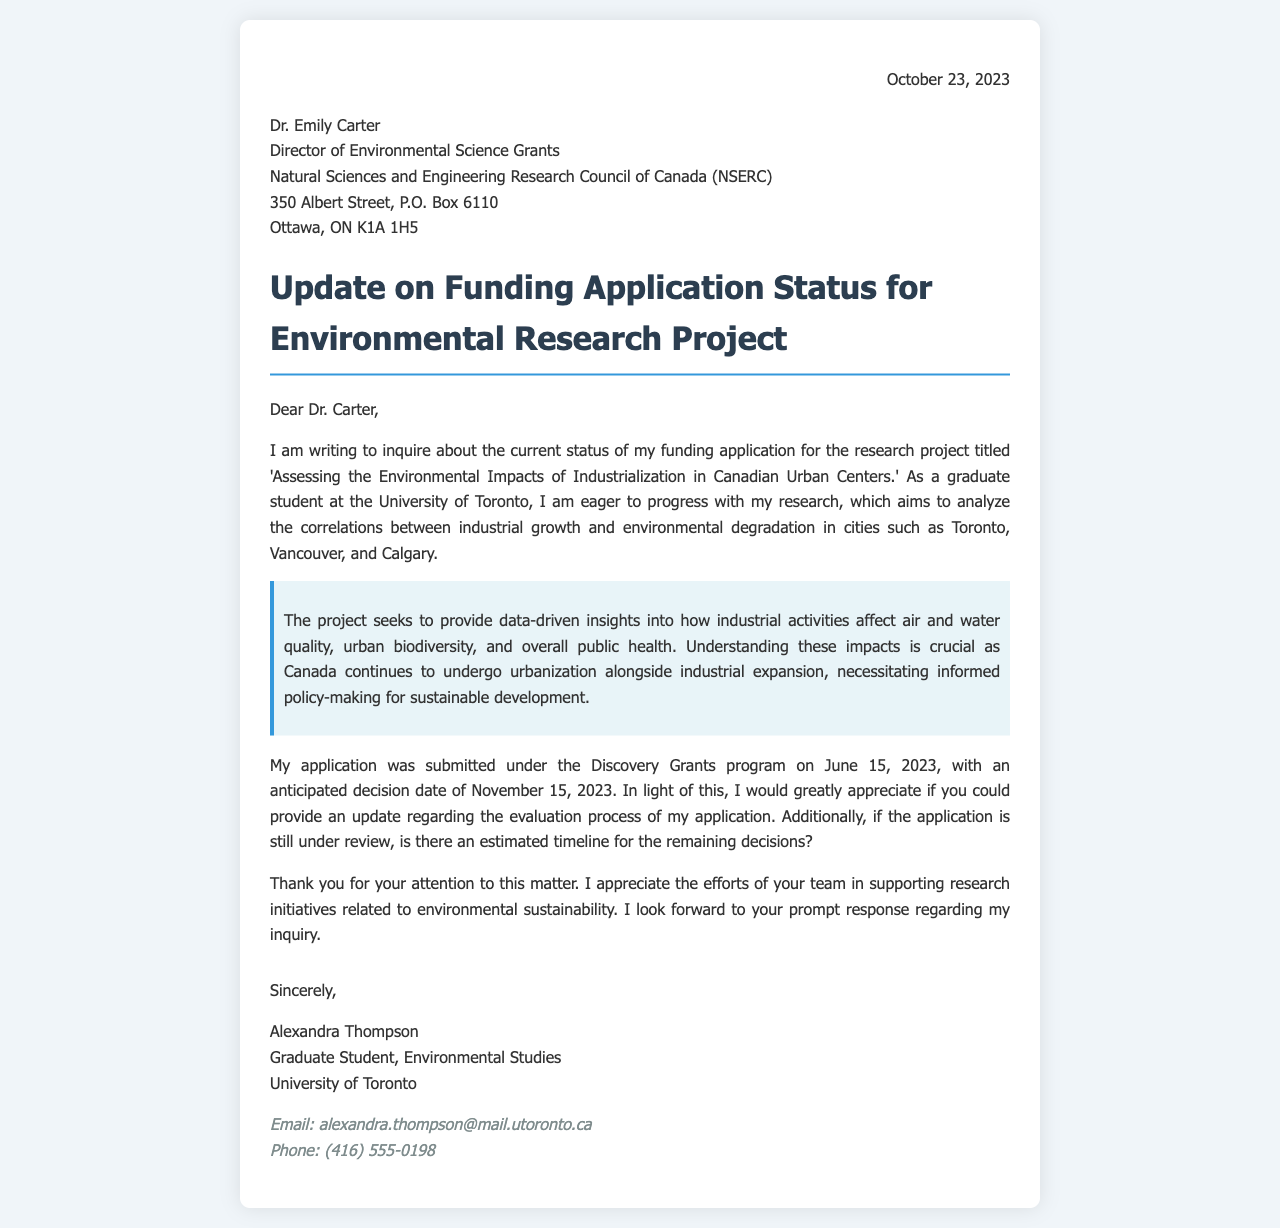What is the date of the letter? The date of the letter is clearly stated at the top of the document.
Answer: October 23, 2023 Who is the recipient of the letter? The recipient's name and title are provided in the section directing the letter.
Answer: Dr. Emily Carter What is the title of the research project? The title is mentioned in the first paragraph of the content section.
Answer: Assessing the Environmental Impacts of Industrialization in Canadian Urban Centers When was the application submitted? The date of application submission is mentioned in the paragraph detailing application information.
Answer: June 15, 2023 What is the anticipated decision date for the application? The anticipated decision date is indicated in the same paragraph as the submission date.
Answer: November 15, 2023 What university is Alexandra Thompson associated with? The university affiliation is mentioned in the signature section of the letter.
Answer: University of Toronto What is the main aim of the research project? The aim of the research project is described in the second paragraph and the highlighted section.
Answer: Analyze the correlations between industrial growth and environmental degradation What program was the application submitted under? The program name is specified in the paragraph that discusses application details.
Answer: Discovery Grants Is there a request for an update on the application status? The inquiry into the application status is clearly articulated in the letter content.
Answer: Yes 